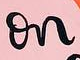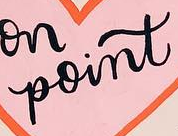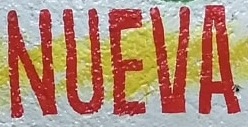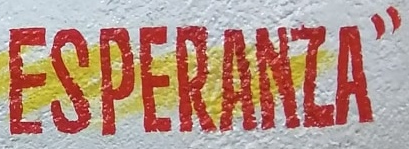What text appears in these images from left to right, separated by a semicolon? on; point; NUEVA; ESPERANZA" 